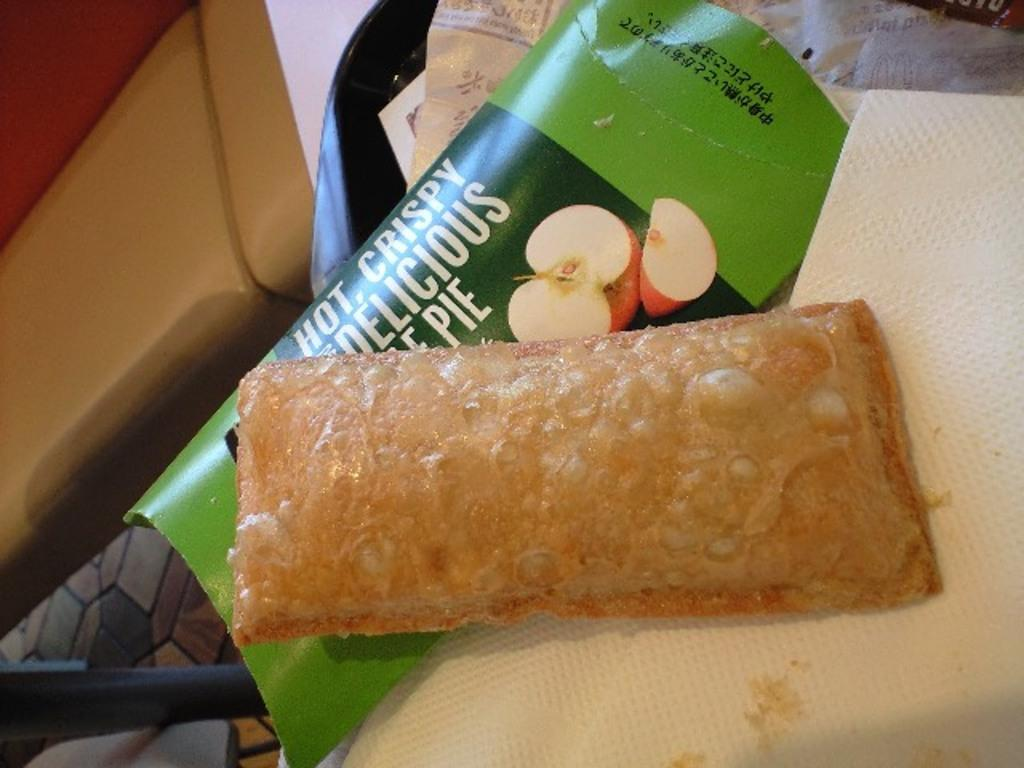What type of food can be seen in the image? There is food in the image, but the specific type is not mentioned. What item might be used for wiping or cleaning in the image? There is a napkin in the image for wiping or cleaning. What type of container is present in the image? There is a wrapper in the tray in the image. How many oranges are visible in the image? There are no oranges present in the image. What type of metal is used to make the cherries in the image? There are no cherries, let alone metal ones, present in the image. 